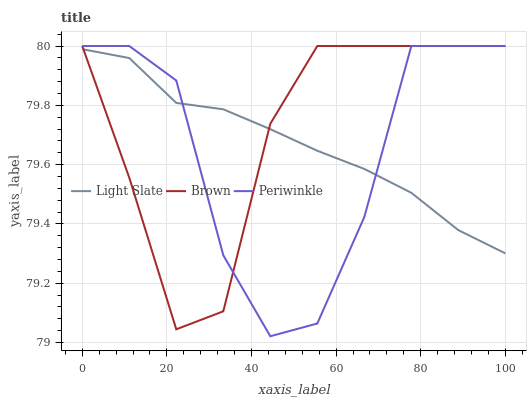Does Periwinkle have the minimum area under the curve?
Answer yes or no. Yes. Does Brown have the maximum area under the curve?
Answer yes or no. Yes. Does Brown have the minimum area under the curve?
Answer yes or no. No. Does Periwinkle have the maximum area under the curve?
Answer yes or no. No. Is Light Slate the smoothest?
Answer yes or no. Yes. Is Periwinkle the roughest?
Answer yes or no. Yes. Is Brown the smoothest?
Answer yes or no. No. Is Brown the roughest?
Answer yes or no. No. Does Brown have the lowest value?
Answer yes or no. No. Does Periwinkle have the highest value?
Answer yes or no. Yes. Does Periwinkle intersect Brown?
Answer yes or no. Yes. Is Periwinkle less than Brown?
Answer yes or no. No. Is Periwinkle greater than Brown?
Answer yes or no. No. 